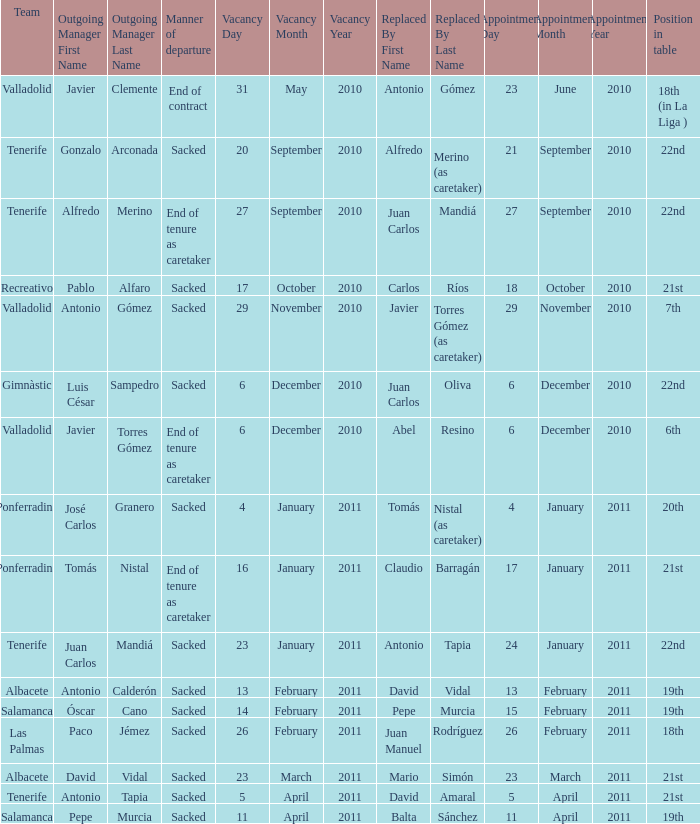How many teams had an appointment date of 11 april 2011 1.0. 